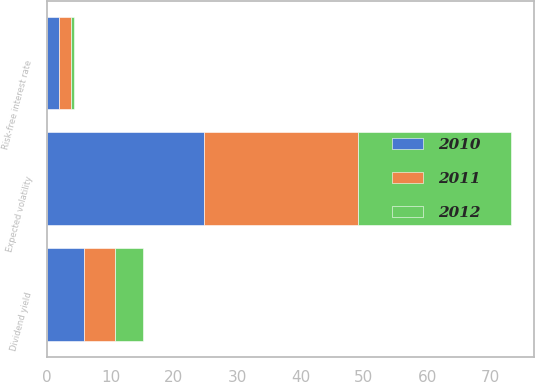Convert chart. <chart><loc_0><loc_0><loc_500><loc_500><stacked_bar_chart><ecel><fcel>Expected volatility<fcel>Risk-free interest rate<fcel>Dividend yield<nl><fcel>2012<fcel>24.1<fcel>0.6<fcel>4.4<nl><fcel>2011<fcel>24.3<fcel>1.8<fcel>4.9<nl><fcel>2010<fcel>24.8<fcel>1.9<fcel>5.8<nl></chart> 